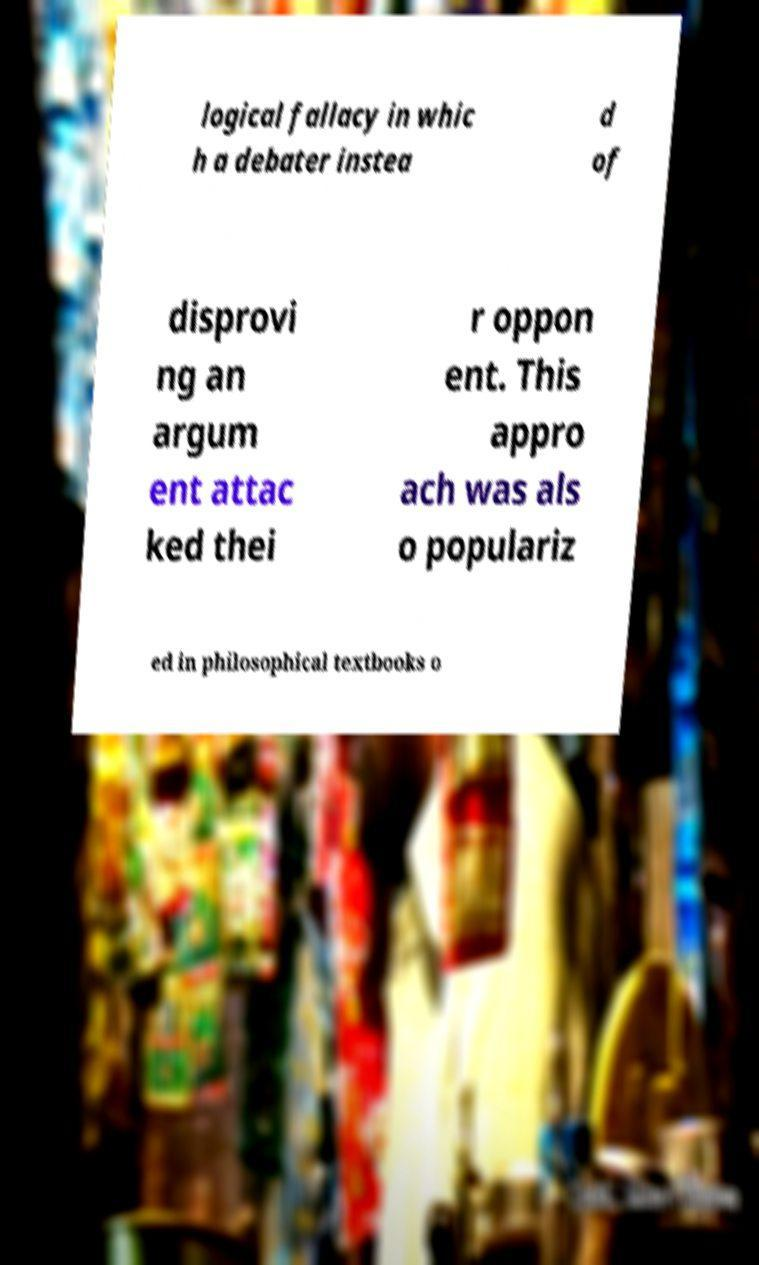What messages or text are displayed in this image? I need them in a readable, typed format. logical fallacy in whic h a debater instea d of disprovi ng an argum ent attac ked thei r oppon ent. This appro ach was als o populariz ed in philosophical textbooks o 